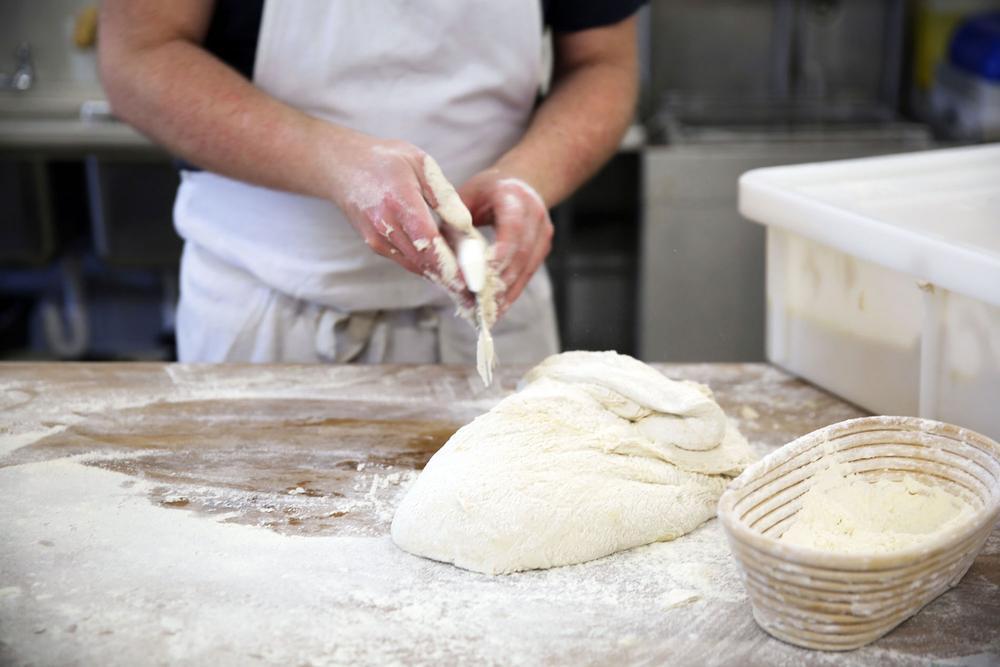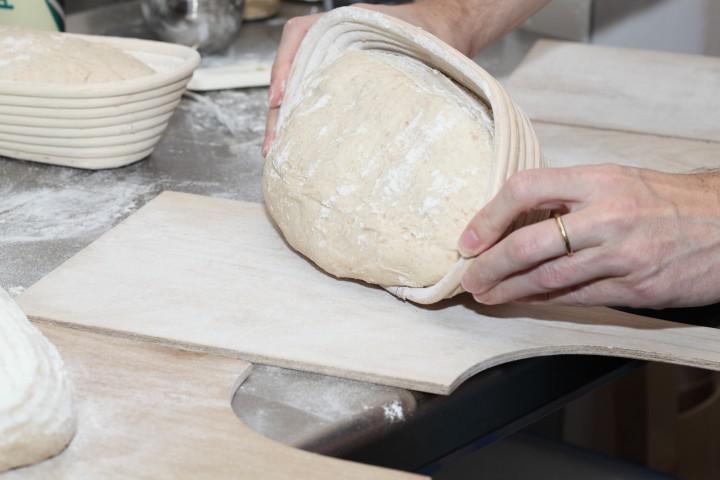The first image is the image on the left, the second image is the image on the right. Assess this claim about the two images: "In one of the images, dough is being transferred out of a ceramic container.". Correct or not? Answer yes or no. Yes. The first image is the image on the left, the second image is the image on the right. Assess this claim about the two images: "The combined images show a mound of dough on a floured wooden counter and dough being dumped out of a loaf pan with ribbed texture.". Correct or not? Answer yes or no. Yes. 